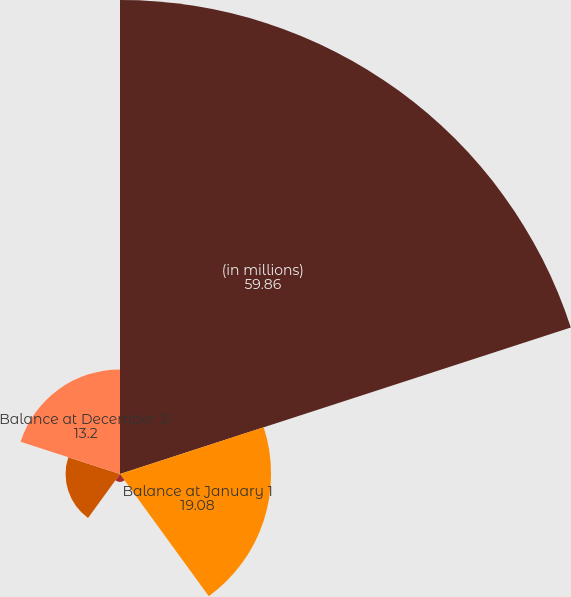Convert chart. <chart><loc_0><loc_0><loc_500><loc_500><pie_chart><fcel>(in millions)<fcel>Balance at January 1<fcel>Reserve increase<fcel>Benefits paid<fcel>Balance at December 31<nl><fcel>59.86%<fcel>19.08%<fcel>0.99%<fcel>6.87%<fcel>13.2%<nl></chart> 